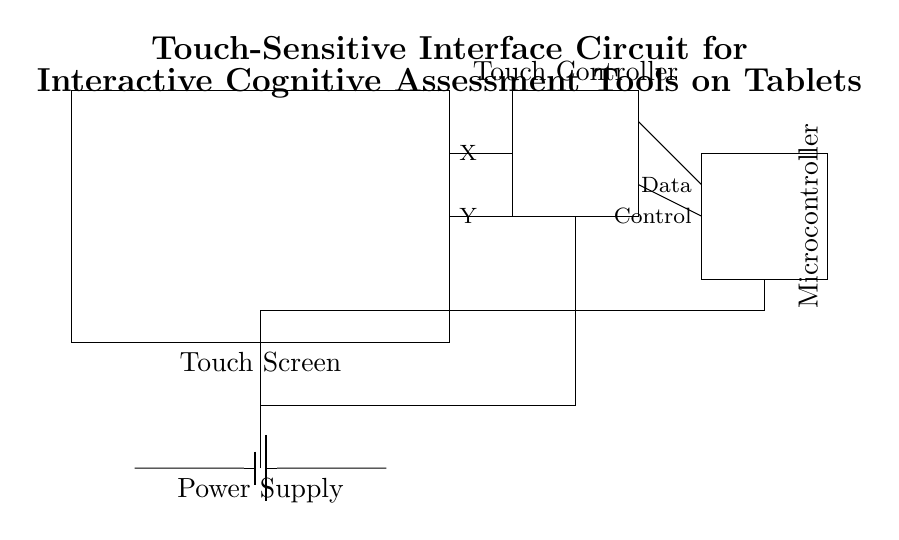What is the type of the power supply used in this circuit? The power supply shown in the diagram is a battery, as indicated by the battery symbol which is typically used to represent a source providing direct current.
Answer: Battery Which component receives the touch inputs? The touch screen component is responsible for detecting user interactions, as it is the interface that directly receives touch inputs from users.
Answer: Touch Screen What are the two types of outputs from the touch controller? The outputs from the touch controller are Data and Control. These can be identified by looking at the labels on the output lines connecting to the microcontroller.
Answer: Data and Control How many main components are in this circuit? The diagram comprises four main components: Touch Screen, Touch Controller, Microcontroller, and Power Supply. Counting each distinct rectangle, we identify these four components.
Answer: Four What is the connection direction between the Touch Screen and Touch Controller? The lines connecting the Touch Screen and Touch Controller are drawn from the right side of the Touch Screen to the left side of the Touch Controller, indicating a right-to-left connection direction.
Answer: Right to left Which component processes the data collected from touch inputs? The microcontroller is responsible for processing the data received from the touch inputs, represented by the Data output line from the touch controller to the microcontroller in the diagram.
Answer: Microcontroller 